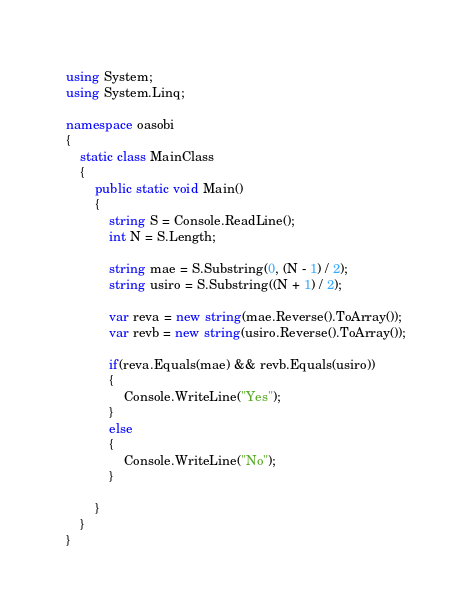Convert code to text. <code><loc_0><loc_0><loc_500><loc_500><_C#_>using System;
using System.Linq;

namespace oasobi
{
    static class MainClass
    {
        public static void Main()
        {
            string S = Console.ReadLine();
            int N = S.Length;

            string mae = S.Substring(0, (N - 1) / 2);
            string usiro = S.Substring((N + 1) / 2);

            var reva = new string(mae.Reverse().ToArray());
            var revb = new string(usiro.Reverse().ToArray());

            if(reva.Equals(mae) && revb.Equals(usiro))
            {
                Console.WriteLine("Yes");
            }
            else
            {
                Console.WriteLine("No");
            }

        }
    }
}</code> 